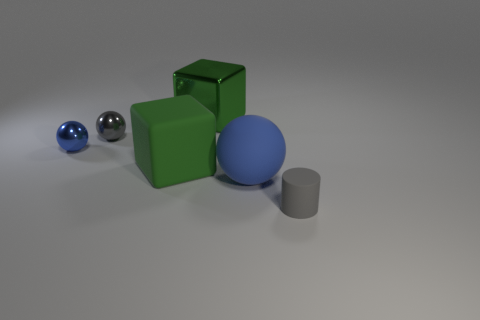Add 1 small blue metallic spheres. How many objects exist? 7 Subtract all cylinders. How many objects are left? 5 Add 3 tiny green things. How many tiny green things exist? 3 Subtract 0 brown cylinders. How many objects are left? 6 Subtract all big red things. Subtract all small metallic spheres. How many objects are left? 4 Add 2 tiny blue spheres. How many tiny blue spheres are left? 3 